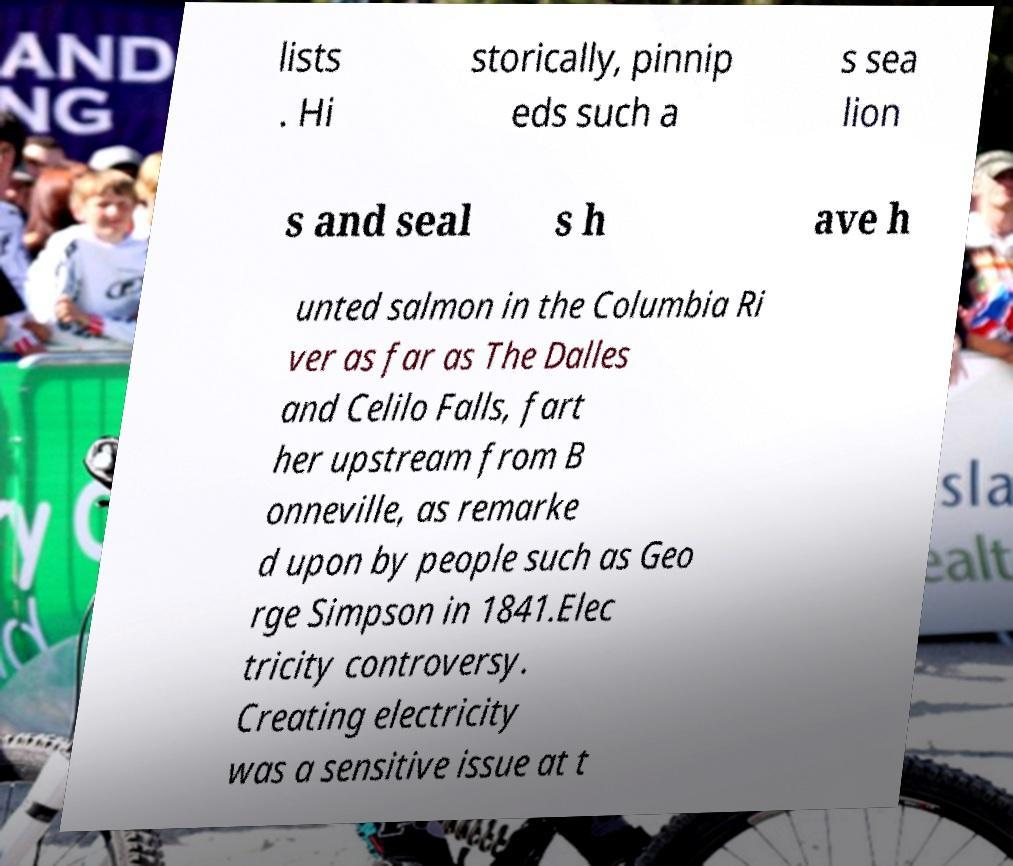Can you accurately transcribe the text from the provided image for me? lists . Hi storically, pinnip eds such a s sea lion s and seal s h ave h unted salmon in the Columbia Ri ver as far as The Dalles and Celilo Falls, fart her upstream from B onneville, as remarke d upon by people such as Geo rge Simpson in 1841.Elec tricity controversy. Creating electricity was a sensitive issue at t 